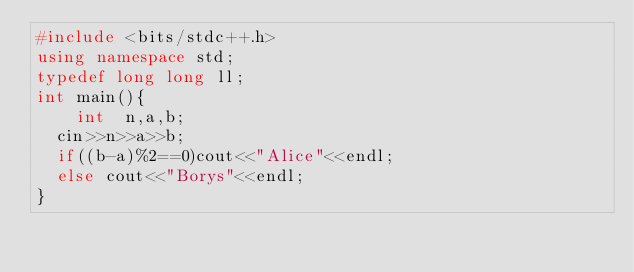Convert code to text. <code><loc_0><loc_0><loc_500><loc_500><_C++_>#include <bits/stdc++.h>
using namespace std;
typedef long long ll;
int main(){
    int  n,a,b;
	cin>>n>>a>>b;
	if((b-a)%2==0)cout<<"Alice"<<endl;
	else cout<<"Borys"<<endl;
}
</code> 